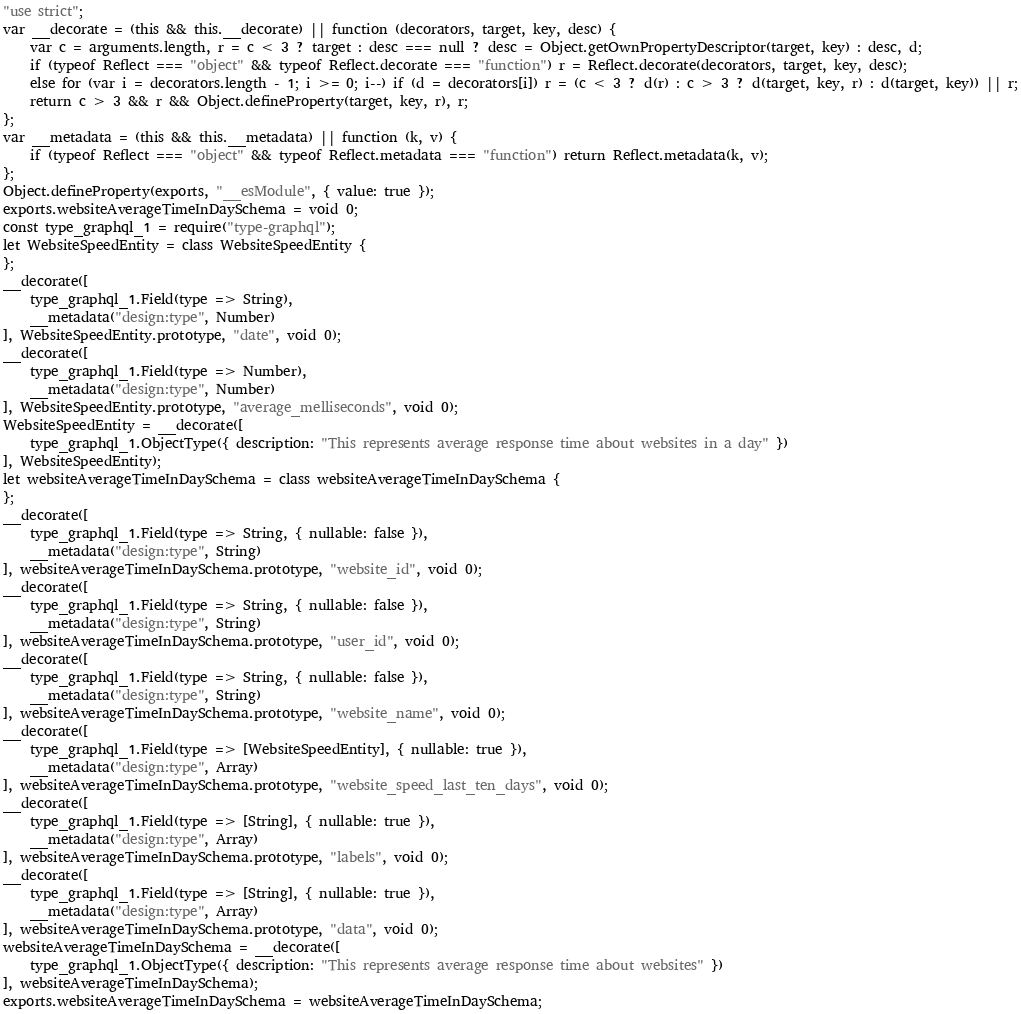<code> <loc_0><loc_0><loc_500><loc_500><_JavaScript_>"use strict";
var __decorate = (this && this.__decorate) || function (decorators, target, key, desc) {
    var c = arguments.length, r = c < 3 ? target : desc === null ? desc = Object.getOwnPropertyDescriptor(target, key) : desc, d;
    if (typeof Reflect === "object" && typeof Reflect.decorate === "function") r = Reflect.decorate(decorators, target, key, desc);
    else for (var i = decorators.length - 1; i >= 0; i--) if (d = decorators[i]) r = (c < 3 ? d(r) : c > 3 ? d(target, key, r) : d(target, key)) || r;
    return c > 3 && r && Object.defineProperty(target, key, r), r;
};
var __metadata = (this && this.__metadata) || function (k, v) {
    if (typeof Reflect === "object" && typeof Reflect.metadata === "function") return Reflect.metadata(k, v);
};
Object.defineProperty(exports, "__esModule", { value: true });
exports.websiteAverageTimeInDaySchema = void 0;
const type_graphql_1 = require("type-graphql");
let WebsiteSpeedEntity = class WebsiteSpeedEntity {
};
__decorate([
    type_graphql_1.Field(type => String),
    __metadata("design:type", Number)
], WebsiteSpeedEntity.prototype, "date", void 0);
__decorate([
    type_graphql_1.Field(type => Number),
    __metadata("design:type", Number)
], WebsiteSpeedEntity.prototype, "average_melliseconds", void 0);
WebsiteSpeedEntity = __decorate([
    type_graphql_1.ObjectType({ description: "This represents average response time about websites in a day" })
], WebsiteSpeedEntity);
let websiteAverageTimeInDaySchema = class websiteAverageTimeInDaySchema {
};
__decorate([
    type_graphql_1.Field(type => String, { nullable: false }),
    __metadata("design:type", String)
], websiteAverageTimeInDaySchema.prototype, "website_id", void 0);
__decorate([
    type_graphql_1.Field(type => String, { nullable: false }),
    __metadata("design:type", String)
], websiteAverageTimeInDaySchema.prototype, "user_id", void 0);
__decorate([
    type_graphql_1.Field(type => String, { nullable: false }),
    __metadata("design:type", String)
], websiteAverageTimeInDaySchema.prototype, "website_name", void 0);
__decorate([
    type_graphql_1.Field(type => [WebsiteSpeedEntity], { nullable: true }),
    __metadata("design:type", Array)
], websiteAverageTimeInDaySchema.prototype, "website_speed_last_ten_days", void 0);
__decorate([
    type_graphql_1.Field(type => [String], { nullable: true }),
    __metadata("design:type", Array)
], websiteAverageTimeInDaySchema.prototype, "labels", void 0);
__decorate([
    type_graphql_1.Field(type => [String], { nullable: true }),
    __metadata("design:type", Array)
], websiteAverageTimeInDaySchema.prototype, "data", void 0);
websiteAverageTimeInDaySchema = __decorate([
    type_graphql_1.ObjectType({ description: "This represents average response time about websites" })
], websiteAverageTimeInDaySchema);
exports.websiteAverageTimeInDaySchema = websiteAverageTimeInDaySchema;
</code> 